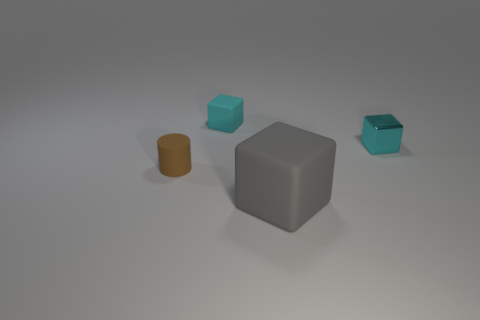Add 4 rubber cubes. How many objects exist? 8 Subtract all cylinders. How many objects are left? 3 Add 3 brown matte cylinders. How many brown matte cylinders exist? 4 Subtract 1 gray cubes. How many objects are left? 3 Subtract all big yellow metal cylinders. Subtract all tiny brown matte things. How many objects are left? 3 Add 4 large gray objects. How many large gray objects are left? 5 